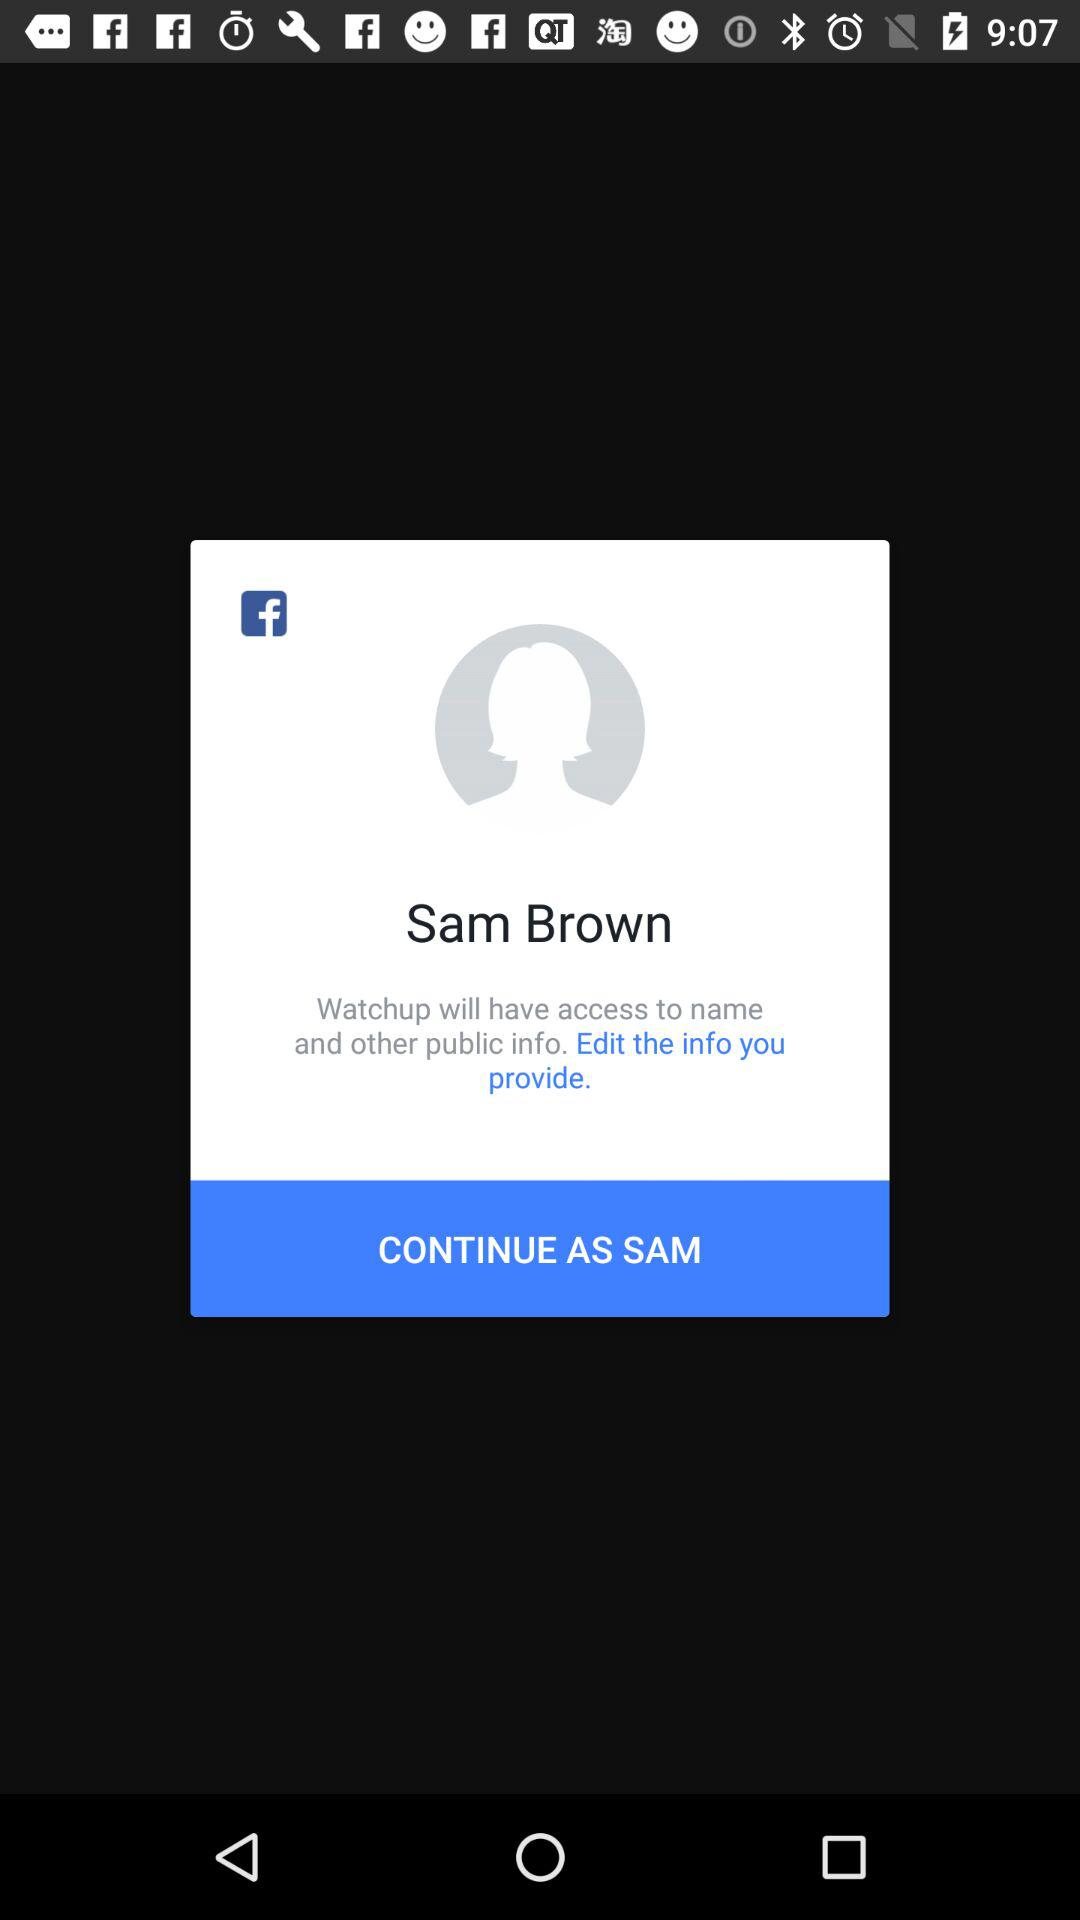What is the name of the user? The name of the user is Sam Brown. 